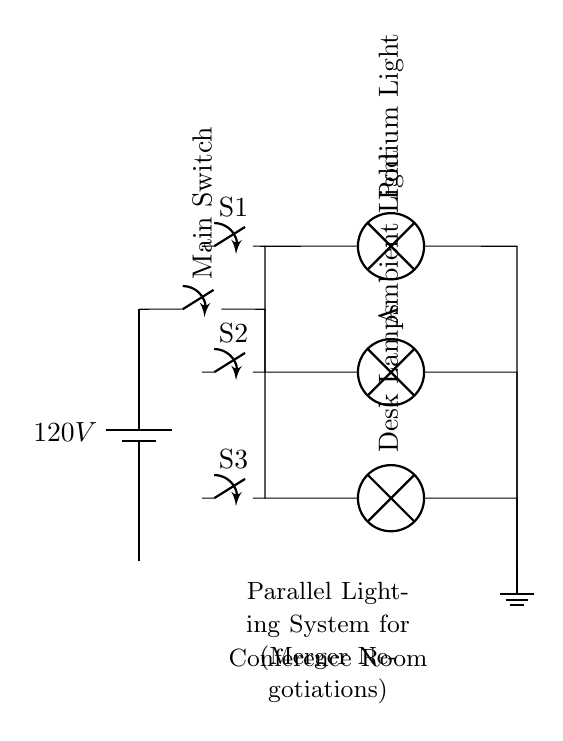What is the total voltage of this circuit? The total voltage of the circuit is given by the battery source, which is 120 volts. In parallel circuits, the voltage across all components remains the same as the source voltage.
Answer: 120 volts How many switches are in this circuit? There are three switches present in the circuit diagram, each corresponding to a separate lighting branch (Podium Light, Ambient Light, Desk Lamps).
Answer: 3 What type of circuit is depicted here? This is a parallel circuit. The configuration allows each lighting component to operate independently, and the current can flow through multiple paths simultaneously.
Answer: Parallel What is the purpose of the main switch in this circuit? The main switch controls the entire lighting system, allowing or interrupting the flow of electricity to all branches simultaneously. It acts as the overall on-off switch for the parallel lighting setup.
Answer: Control entire system Which light has a switch labeled S1? The switch labeled S1 controls the Podium Light according to its placement in the circuit diagram. This switch allows for independent operation of that specific light.
Answer: Podium Light What happens if one lamp goes out in this circuit? If one lamp goes out, the other lamps will continue to operate because they are connected in parallel. This characteristic means that failure or disconnection of one branch does not affect the others.
Answer: Others continue to operate What does the ground symbol represent in this circuit? The ground symbol represents a common reference point for electrical potential within the circuit. It ensures safety by providing a path for excess current to flow safely into the earth.
Answer: Safety reference point 